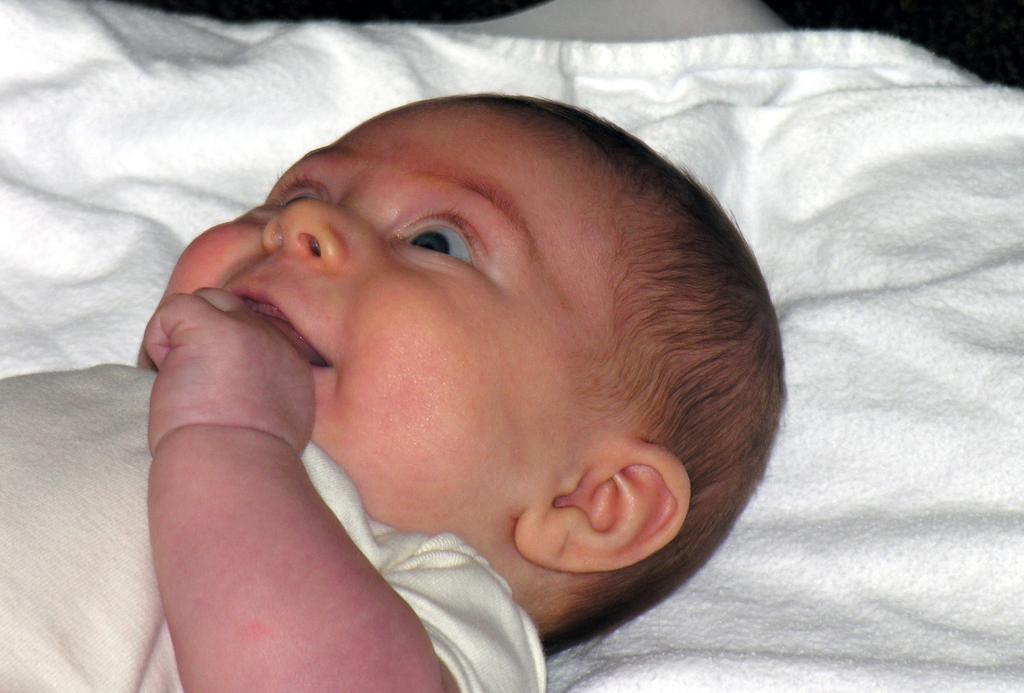Could you give a brief overview of what you see in this image? In this image I can see the child lying on the white color cloth. I can see there is a white background. 